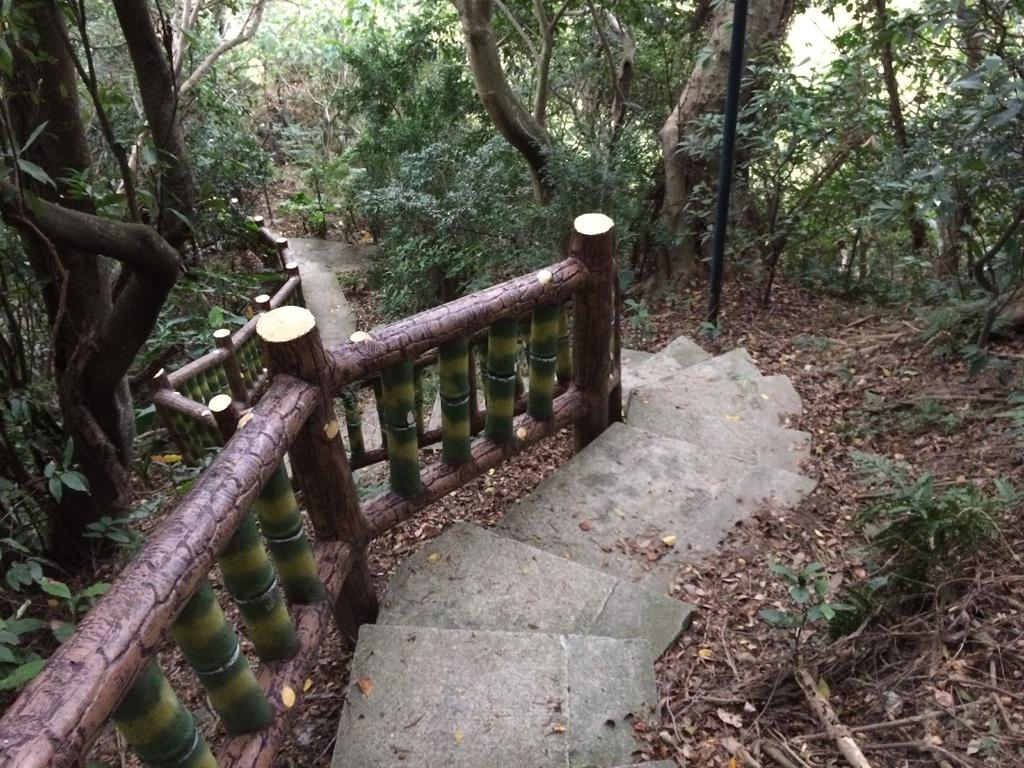What type of structure is present in the image? There are stairs in the image. What is covering the ground in the image? Shredded leaves are present in the image. What are the people in the image doing? Climbers are visible in the image. What is used for support while climbing the stairs? There is a wooden railing in the image. What is the pole used for in the image? A pole is present in the image, but its purpose is not specified. What type of natural environment is visible in the image? Trees are visible in the image. What type of appliance is being used by the climbers in the image? There is no appliance visible in the image; the climbers are using a wooden railing for support. How many cubs are visible in the image? There are no cubs present in the image. 